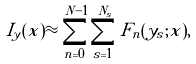<formula> <loc_0><loc_0><loc_500><loc_500>I _ { y } ( x ) \approx \sum _ { n = 0 } ^ { N - 1 } \sum _ { s = 1 } ^ { N _ { s } } F _ { n } ( y _ { s } ; x ) ,</formula> 